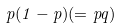<formula> <loc_0><loc_0><loc_500><loc_500>p ( 1 - p ) ( = p q )</formula> 